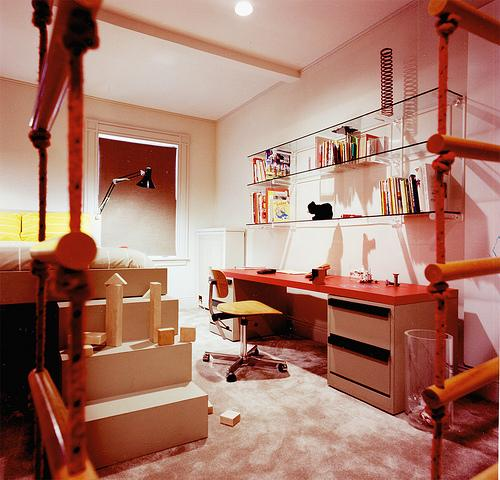Who uses this room?

Choices:
A) older adult
B) child
C) teenager
D) young adult child 